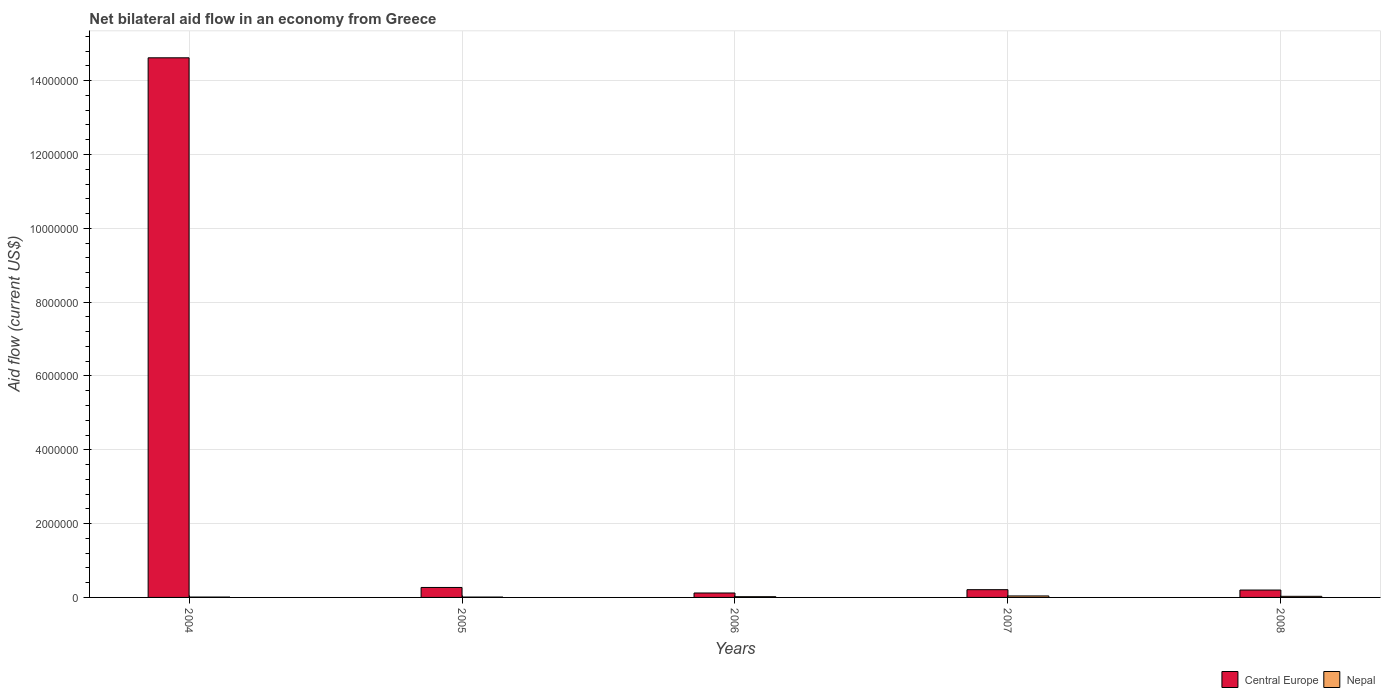Are the number of bars per tick equal to the number of legend labels?
Provide a succinct answer. Yes. Are the number of bars on each tick of the X-axis equal?
Make the answer very short. Yes. How many bars are there on the 5th tick from the right?
Keep it short and to the point. 2. What is the label of the 4th group of bars from the left?
Provide a short and direct response. 2007. In how many cases, is the number of bars for a given year not equal to the number of legend labels?
Provide a short and direct response. 0. What is the net bilateral aid flow in Nepal in 2008?
Make the answer very short. 3.00e+04. Across all years, what is the maximum net bilateral aid flow in Central Europe?
Offer a terse response. 1.46e+07. Across all years, what is the minimum net bilateral aid flow in Nepal?
Ensure brevity in your answer.  10000. In which year was the net bilateral aid flow in Nepal minimum?
Your response must be concise. 2004. What is the total net bilateral aid flow in Central Europe in the graph?
Ensure brevity in your answer.  1.54e+07. What is the average net bilateral aid flow in Central Europe per year?
Your answer should be compact. 3.08e+06. In the year 2008, what is the difference between the net bilateral aid flow in Nepal and net bilateral aid flow in Central Europe?
Offer a terse response. -1.70e+05. In how many years, is the net bilateral aid flow in Central Europe greater than 9200000 US$?
Make the answer very short. 1. What is the ratio of the net bilateral aid flow in Central Europe in 2006 to that in 2008?
Offer a terse response. 0.6. Is the net bilateral aid flow in Nepal in 2004 less than that in 2006?
Provide a short and direct response. Yes. What is the difference between the highest and the second highest net bilateral aid flow in Nepal?
Make the answer very short. 10000. What is the difference between the highest and the lowest net bilateral aid flow in Nepal?
Give a very brief answer. 3.00e+04. What does the 2nd bar from the left in 2007 represents?
Ensure brevity in your answer.  Nepal. What does the 1st bar from the right in 2005 represents?
Your response must be concise. Nepal. Are all the bars in the graph horizontal?
Your answer should be very brief. No. What is the difference between two consecutive major ticks on the Y-axis?
Offer a very short reply. 2.00e+06. Are the values on the major ticks of Y-axis written in scientific E-notation?
Offer a very short reply. No. How many legend labels are there?
Offer a terse response. 2. How are the legend labels stacked?
Your answer should be compact. Horizontal. What is the title of the graph?
Ensure brevity in your answer.  Net bilateral aid flow in an economy from Greece. Does "Mauritius" appear as one of the legend labels in the graph?
Provide a short and direct response. No. What is the label or title of the X-axis?
Ensure brevity in your answer.  Years. What is the Aid flow (current US$) of Central Europe in 2004?
Offer a very short reply. 1.46e+07. What is the Aid flow (current US$) in Nepal in 2007?
Provide a succinct answer. 4.00e+04. What is the Aid flow (current US$) of Nepal in 2008?
Keep it short and to the point. 3.00e+04. Across all years, what is the maximum Aid flow (current US$) in Central Europe?
Provide a short and direct response. 1.46e+07. Across all years, what is the minimum Aid flow (current US$) of Central Europe?
Give a very brief answer. 1.20e+05. What is the total Aid flow (current US$) in Central Europe in the graph?
Provide a succinct answer. 1.54e+07. What is the difference between the Aid flow (current US$) of Central Europe in 2004 and that in 2005?
Your response must be concise. 1.44e+07. What is the difference between the Aid flow (current US$) of Central Europe in 2004 and that in 2006?
Provide a succinct answer. 1.45e+07. What is the difference between the Aid flow (current US$) of Nepal in 2004 and that in 2006?
Provide a succinct answer. -10000. What is the difference between the Aid flow (current US$) of Central Europe in 2004 and that in 2007?
Your answer should be compact. 1.44e+07. What is the difference between the Aid flow (current US$) of Nepal in 2004 and that in 2007?
Keep it short and to the point. -3.00e+04. What is the difference between the Aid flow (current US$) of Central Europe in 2004 and that in 2008?
Give a very brief answer. 1.44e+07. What is the difference between the Aid flow (current US$) of Central Europe in 2005 and that in 2006?
Your response must be concise. 1.50e+05. What is the difference between the Aid flow (current US$) in Nepal in 2005 and that in 2006?
Provide a succinct answer. -10000. What is the difference between the Aid flow (current US$) of Central Europe in 2005 and that in 2007?
Provide a short and direct response. 6.00e+04. What is the difference between the Aid flow (current US$) of Nepal in 2005 and that in 2007?
Offer a terse response. -3.00e+04. What is the difference between the Aid flow (current US$) of Nepal in 2005 and that in 2008?
Provide a short and direct response. -2.00e+04. What is the difference between the Aid flow (current US$) of Central Europe in 2007 and that in 2008?
Ensure brevity in your answer.  10000. What is the difference between the Aid flow (current US$) of Central Europe in 2004 and the Aid flow (current US$) of Nepal in 2005?
Offer a terse response. 1.46e+07. What is the difference between the Aid flow (current US$) of Central Europe in 2004 and the Aid flow (current US$) of Nepal in 2006?
Make the answer very short. 1.46e+07. What is the difference between the Aid flow (current US$) in Central Europe in 2004 and the Aid flow (current US$) in Nepal in 2007?
Offer a very short reply. 1.46e+07. What is the difference between the Aid flow (current US$) of Central Europe in 2004 and the Aid flow (current US$) of Nepal in 2008?
Your answer should be compact. 1.46e+07. What is the difference between the Aid flow (current US$) in Central Europe in 2006 and the Aid flow (current US$) in Nepal in 2007?
Your answer should be very brief. 8.00e+04. What is the difference between the Aid flow (current US$) in Central Europe in 2006 and the Aid flow (current US$) in Nepal in 2008?
Give a very brief answer. 9.00e+04. What is the average Aid flow (current US$) in Central Europe per year?
Provide a short and direct response. 3.08e+06. What is the average Aid flow (current US$) of Nepal per year?
Your answer should be very brief. 2.20e+04. In the year 2004, what is the difference between the Aid flow (current US$) in Central Europe and Aid flow (current US$) in Nepal?
Your response must be concise. 1.46e+07. In the year 2006, what is the difference between the Aid flow (current US$) of Central Europe and Aid flow (current US$) of Nepal?
Provide a short and direct response. 1.00e+05. In the year 2007, what is the difference between the Aid flow (current US$) in Central Europe and Aid flow (current US$) in Nepal?
Provide a short and direct response. 1.70e+05. In the year 2008, what is the difference between the Aid flow (current US$) in Central Europe and Aid flow (current US$) in Nepal?
Keep it short and to the point. 1.70e+05. What is the ratio of the Aid flow (current US$) of Central Europe in 2004 to that in 2005?
Ensure brevity in your answer.  54.15. What is the ratio of the Aid flow (current US$) in Nepal in 2004 to that in 2005?
Ensure brevity in your answer.  1. What is the ratio of the Aid flow (current US$) in Central Europe in 2004 to that in 2006?
Keep it short and to the point. 121.83. What is the ratio of the Aid flow (current US$) in Nepal in 2004 to that in 2006?
Make the answer very short. 0.5. What is the ratio of the Aid flow (current US$) in Central Europe in 2004 to that in 2007?
Provide a succinct answer. 69.62. What is the ratio of the Aid flow (current US$) of Nepal in 2004 to that in 2007?
Provide a succinct answer. 0.25. What is the ratio of the Aid flow (current US$) of Central Europe in 2004 to that in 2008?
Offer a terse response. 73.1. What is the ratio of the Aid flow (current US$) of Central Europe in 2005 to that in 2006?
Offer a very short reply. 2.25. What is the ratio of the Aid flow (current US$) in Central Europe in 2005 to that in 2008?
Your response must be concise. 1.35. What is the ratio of the Aid flow (current US$) in Nepal in 2005 to that in 2008?
Give a very brief answer. 0.33. What is the ratio of the Aid flow (current US$) in Nepal in 2006 to that in 2007?
Provide a succinct answer. 0.5. What is the ratio of the Aid flow (current US$) in Central Europe in 2007 to that in 2008?
Keep it short and to the point. 1.05. What is the difference between the highest and the second highest Aid flow (current US$) in Central Europe?
Keep it short and to the point. 1.44e+07. What is the difference between the highest and the second highest Aid flow (current US$) of Nepal?
Ensure brevity in your answer.  10000. What is the difference between the highest and the lowest Aid flow (current US$) in Central Europe?
Keep it short and to the point. 1.45e+07. 